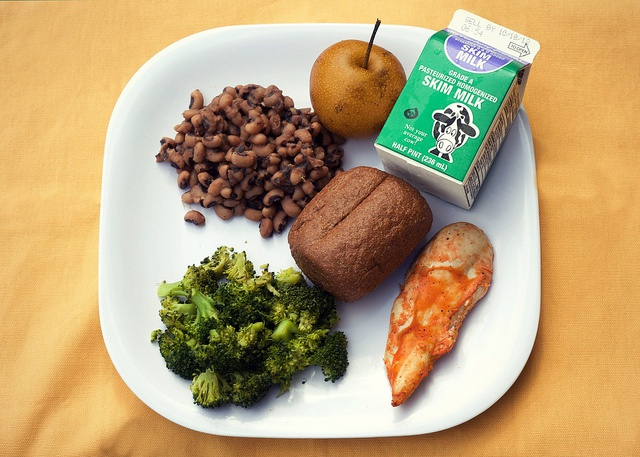Describe the objects in this image and their specific colors. I can see broccoli in olive, black, and darkgreen tones and orange in olive, brown, maroon, and orange tones in this image. 